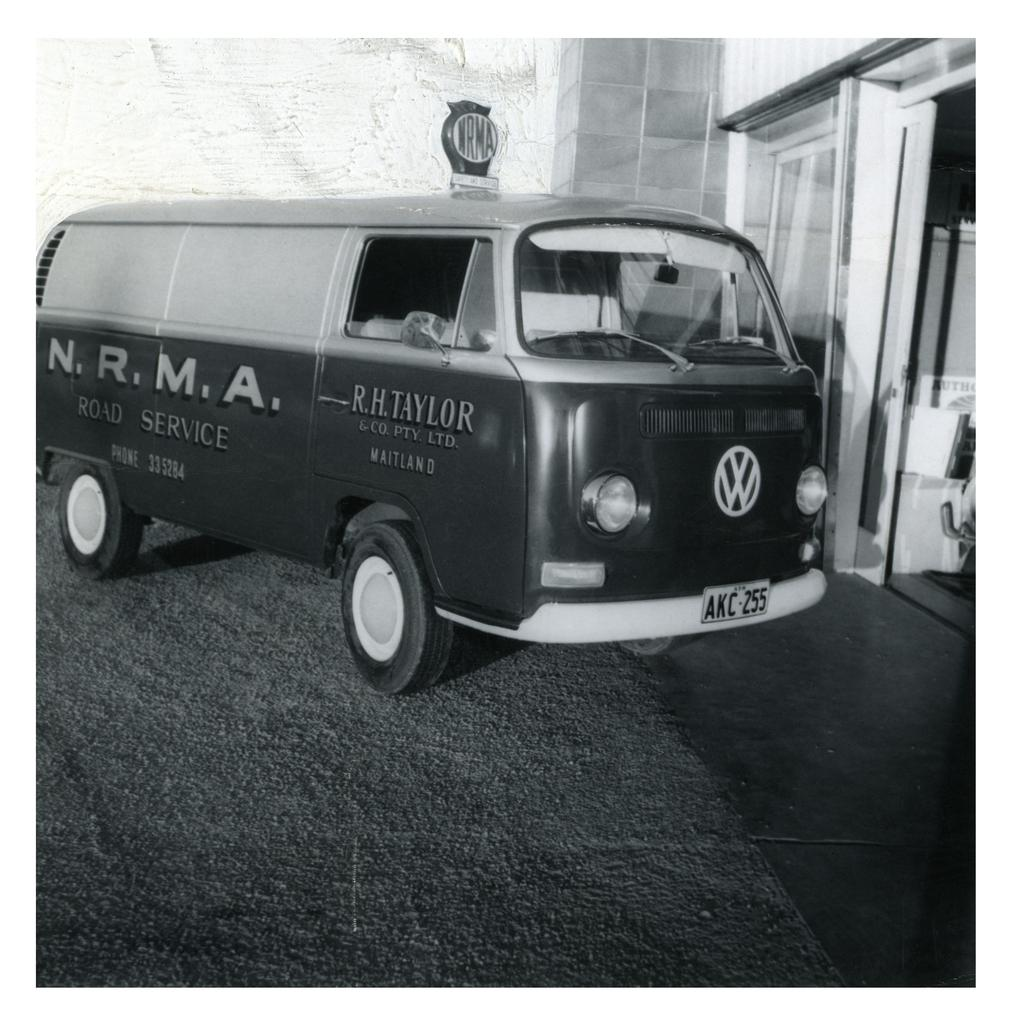<image>
Describe the image concisely. A Volkswagon bus that says RH Taylor on the passenger door. 